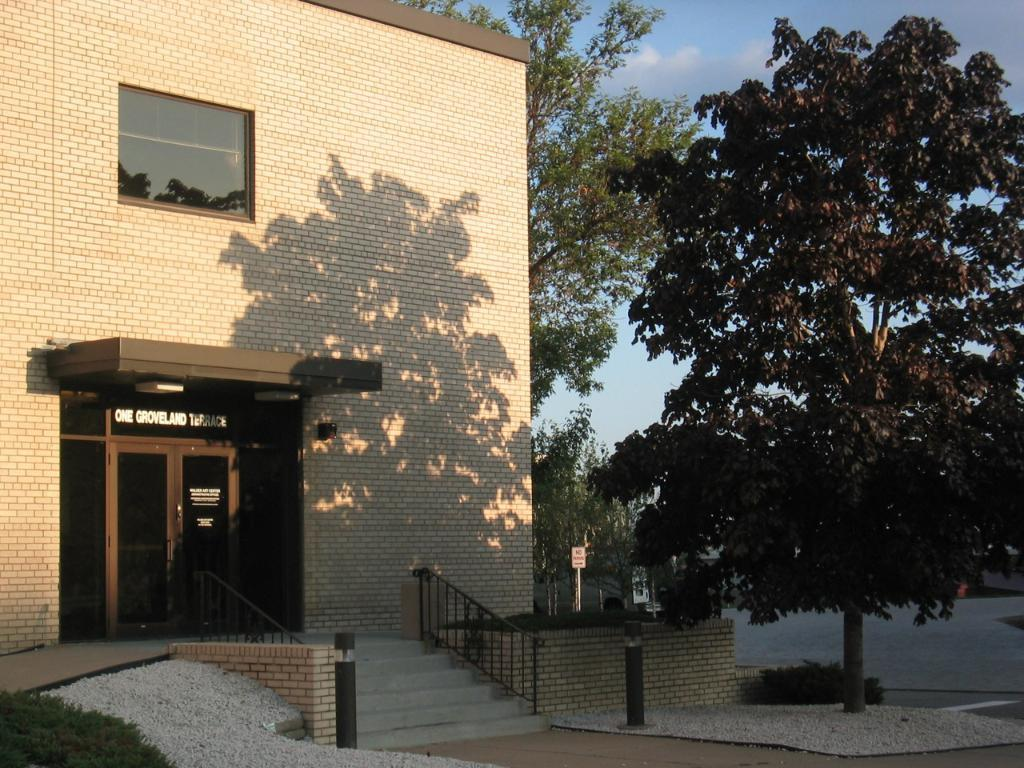What type of structure is present in the image? There is a building in the image. What architectural feature can be seen in the image? There are stairs in the image. What type of material is used for the grilles in the image? There are iron grilles in the image. What type of vegetation is present in the image? There are plants and trees in the image. What is visible in the background of the image? The sky is visible in the background of the image. Where is the umbrella being used in the image? There is no umbrella present in the image. What type of twig can be seen in the image? There is no twig present in the image. 